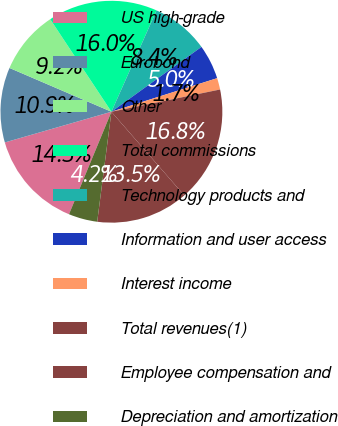Convert chart. <chart><loc_0><loc_0><loc_500><loc_500><pie_chart><fcel>US high-grade<fcel>Eurobond<fcel>Other<fcel>Total commissions<fcel>Technology products and<fcel>Information and user access<fcel>Interest income<fcel>Total revenues(1)<fcel>Employee compensation and<fcel>Depreciation and amortization<nl><fcel>14.29%<fcel>10.92%<fcel>9.24%<fcel>15.97%<fcel>8.4%<fcel>5.04%<fcel>1.68%<fcel>16.81%<fcel>13.45%<fcel>4.2%<nl></chart> 